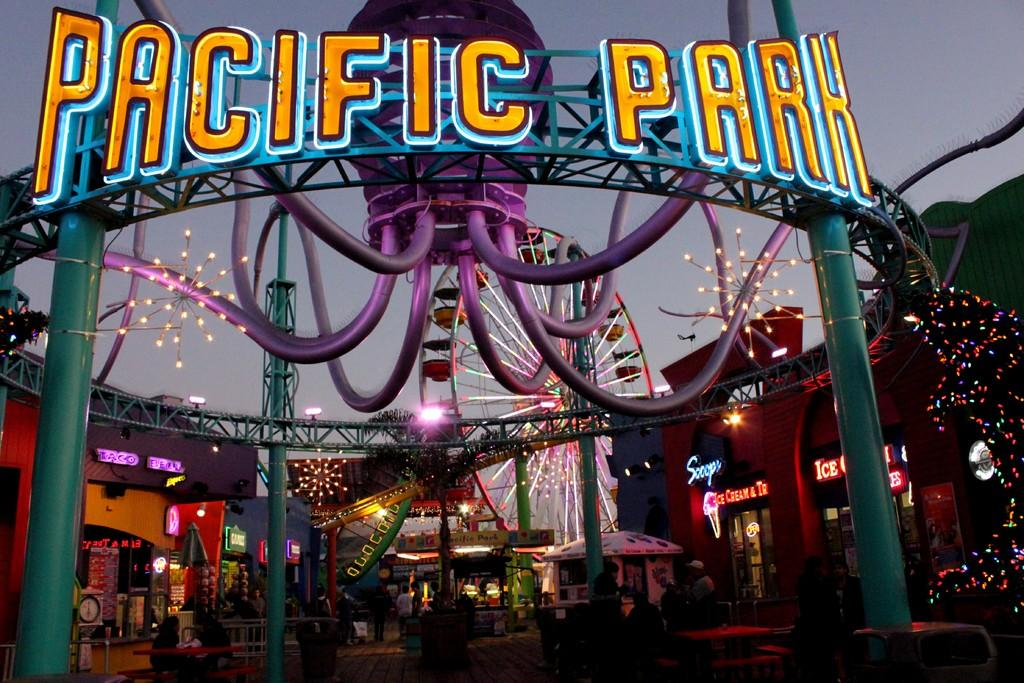What is happening in the image? There is an exhibition in the image. What are the people at the bottom of the image doing? The people are standing and walking at the bottom of the image. What can be seen in the background of the image? The sky is visible in the background of the image. What type of ice can be seen melting on the kettle in the image? There is no ice or kettle present in the image; it features an exhibition with people standing and walking. What day of the week is the exhibition taking place on? The day of the week is not mentioned or visible in the image, so it cannot be determined. 